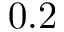<formula> <loc_0><loc_0><loc_500><loc_500>0 . 2</formula> 